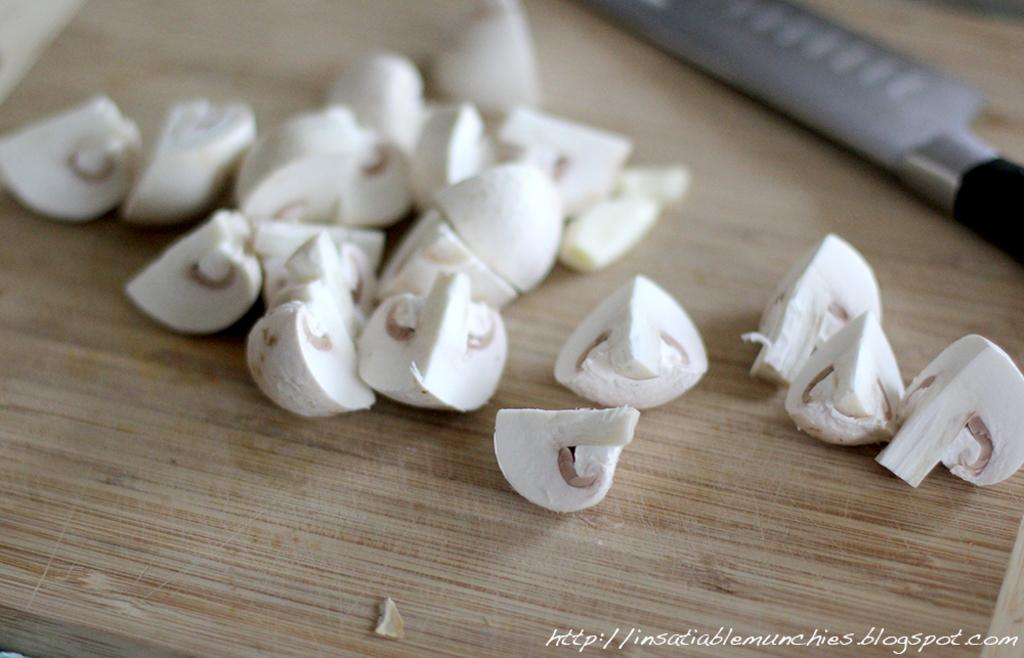What is on the chopping board in the image? There are mushroom pieces on the chopping board. What tool is used for cutting the mushrooms in the image? There is a knife on the chopping board. Is there any text or marking visible in the image? Yes, there is a watermark in the bottom right side of the image. How many women are giving advice on the roof in the image? There are no women or roof present in the image. 